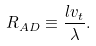Convert formula to latex. <formula><loc_0><loc_0><loc_500><loc_500>R _ { A D } \equiv \frac { l v _ { t } } { \lambda } .</formula> 